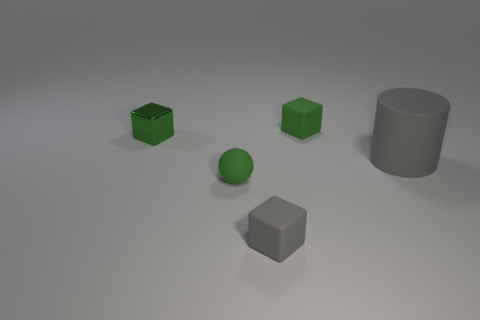Is the number of shiny things that are in front of the gray rubber block the same as the number of tiny matte cubes on the right side of the gray cylinder?
Your answer should be compact. Yes. What number of other metallic blocks have the same color as the tiny shiny block?
Your response must be concise. 0. There is a tiny thing that is the same color as the big cylinder; what is its material?
Your answer should be compact. Rubber. How many metal objects are either cylinders or green things?
Provide a short and direct response. 1. Is the shape of the gray rubber thing that is on the left side of the large gray matte thing the same as the green rubber thing behind the large rubber object?
Provide a short and direct response. Yes. How many green blocks are to the right of the small green matte cube?
Provide a short and direct response. 0. Is there a yellow block made of the same material as the big cylinder?
Offer a very short reply. No. There is a gray cube that is the same size as the green metal cube; what is its material?
Provide a short and direct response. Rubber. Do the big gray cylinder and the tiny green ball have the same material?
Keep it short and to the point. Yes. How many things are either small purple spheres or small green matte cubes?
Provide a succinct answer. 1. 